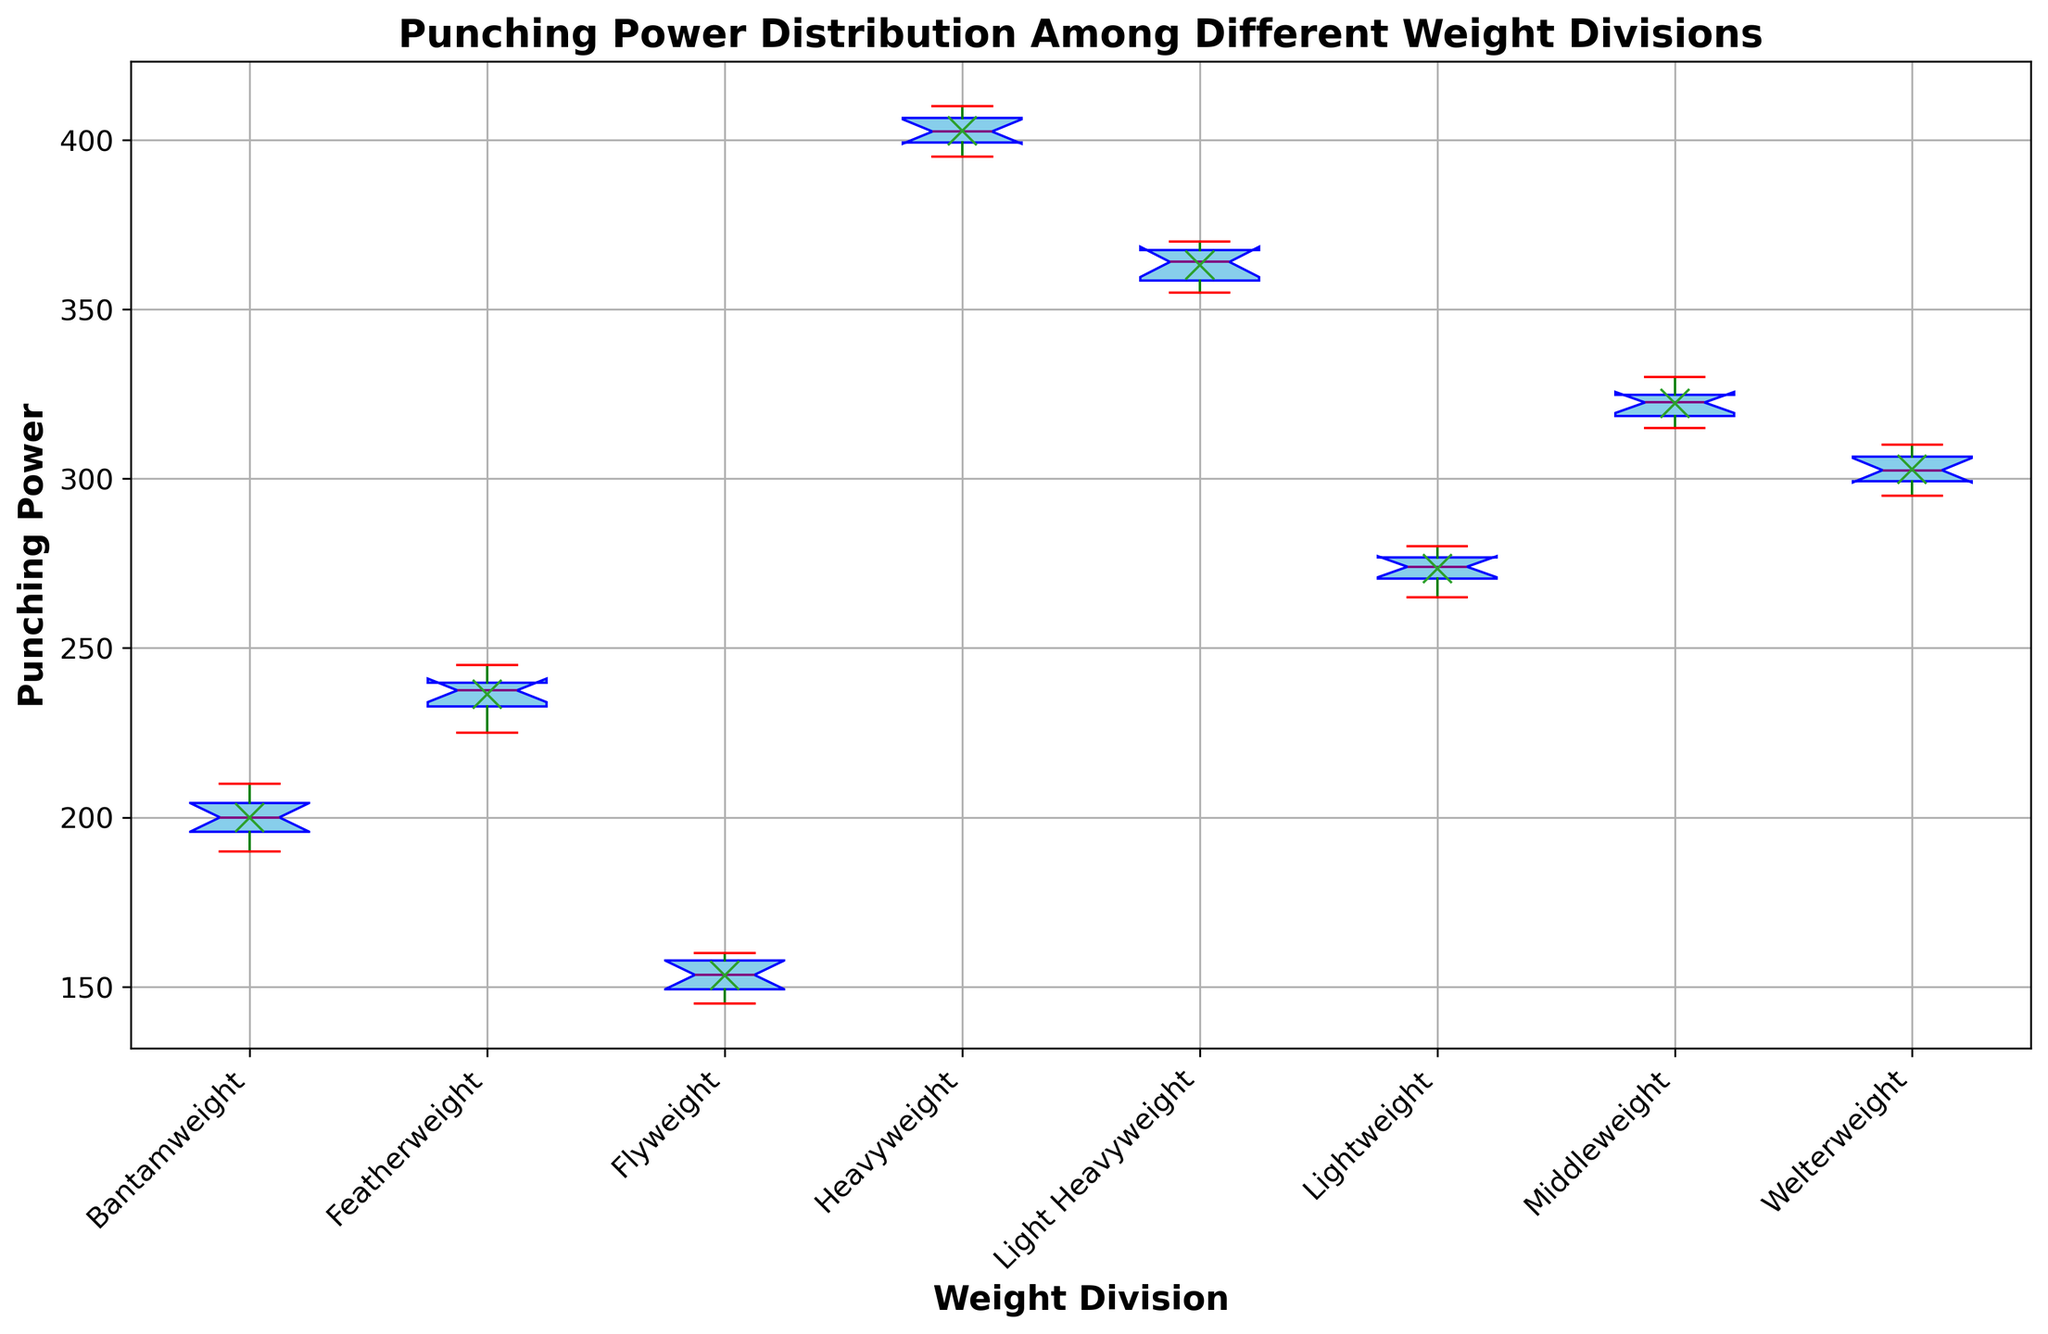What is the median punching power for the Lightweight division? The median is the value that separates the higher half from the lower half of the data. In the box plot, the median is indicated by the horizontal line inside the box. For the Lightweight division, the median punching power is 273.
Answer: 273 Which weight division has the highest median punching power? By observing the position of the median lines (the horizontal line inside each box) across all divisions, you can determine the highest one. The Heavyweight division has the highest median punching power.
Answer: Heavyweight How do the means of Lightweight and Middleweight divisions compare? The mean is indicated by the 'x' marker in each box plot. Comparing the positions of the 'x' markers for the Lightweight and Middleweight divisions visually, the Lightweight division has a higher mean than the Middleweight division.
Answer: Lightweight has a higher mean What is the interquartile range (IQR) for the Featherweight division? The interquartile range is the distance between the first quartile (Q1) and the third quartile (Q3), which correspond to the edges of the box. For the Featherweight division, Q1 and Q3 can be visually estimated. Q1 is around 231 and Q3 is around 241, so the IQR is 241 - 231.
Answer: 10 Are there any outliers in the Flyweight division? Outliers are typically marked as individual points beyond the whiskers of the box plot. There are red markers indicating that there are no outliers in the Flyweight division.
Answer: No Which weight division has the widest range of punching power? The range is the distance between the minimum and maximum values, indicated by the whiskers' ends. Visually, the Heavyweight division has the widest range.
Answer: Heavyweight Compare the medians of Flyweight and Bantamweight divisions. Which one is higher? The median values are indicated by the horizontal lines inside the boxes. The median for the Bantamweight division is higher than the median for the Flyweight division.
Answer: Bantamweight How does the variance of punching power in the Lightweight division compare to that in the Welterweight division? Variance can be visually inferred by the spread of the data points. A larger spread in the box and whiskers generally indicates higher variance. The Lightweight division shows a narrower spread compared to the Welterweight division, indicating lower variance.
Answer: Lightweight has lower variance Are there any weight divisions where the mean punching power falls below all the means of other divisions? The mean is indicated by the 'x' marker. By comparing them across all divisions, we see that the Flyweight division has the lowest mean punching power, but it doesn't fall below all means of other divisions.
Answer: No What is the significance of the color attributes of the box plot? Different colors indicate different components of the box plot: blue for the box (which shows the interquartile range), red for the caps (which show the endpoints of the data excluding outliers), green for the whiskers (which show the range within 1.5 IQR of the median), and purple for the median. This color-coding helps in easily identifying different components of the plot.
Answer: Differentiating components 